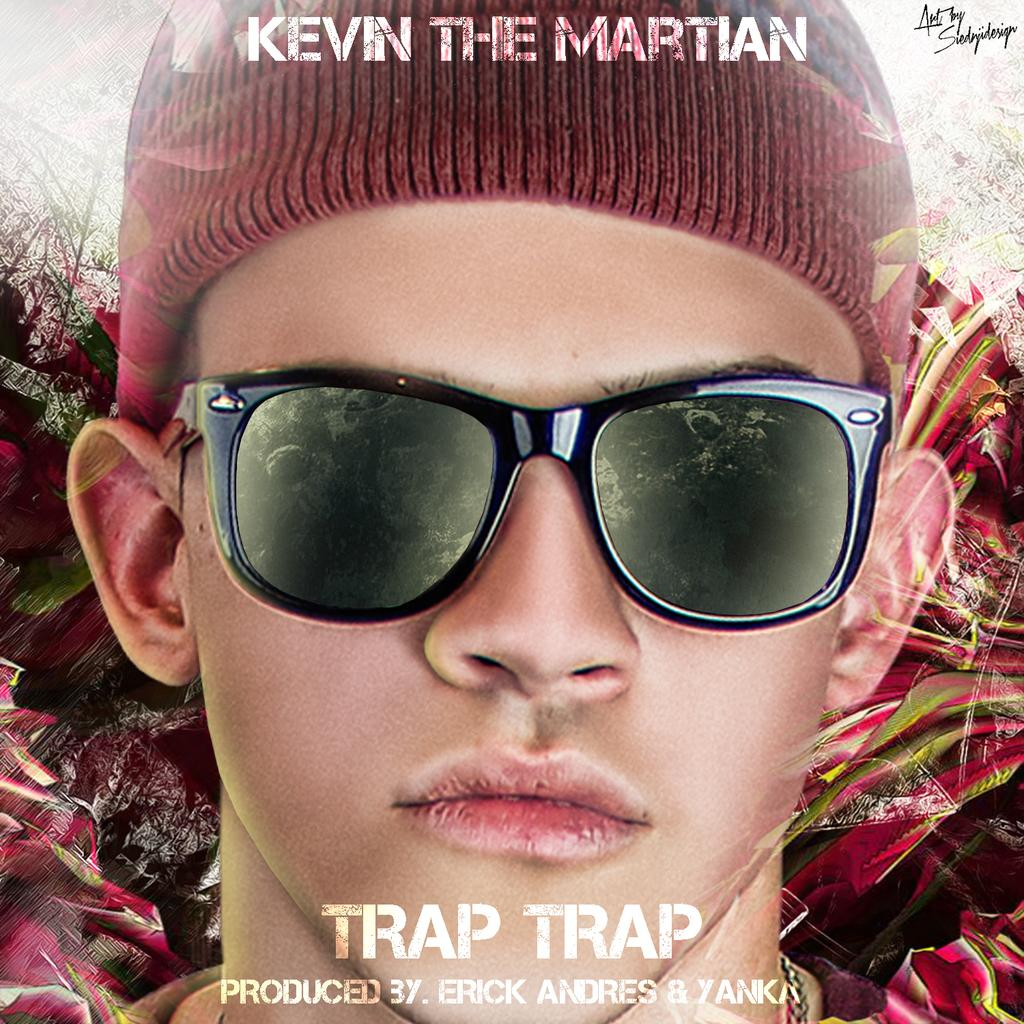<image>
Summarize the visual content of the image. An advert for Kevin The Martian in  Trap TRAP  produced  by Erick Andres .... 